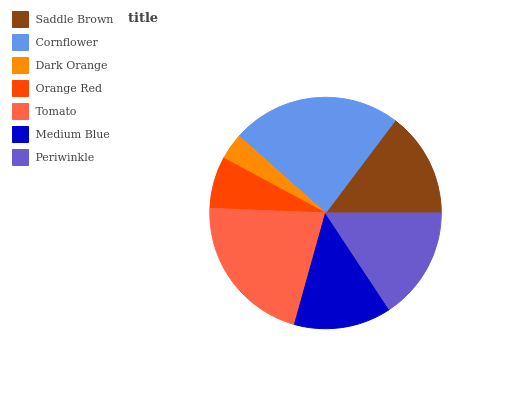Is Dark Orange the minimum?
Answer yes or no. Yes. Is Cornflower the maximum?
Answer yes or no. Yes. Is Cornflower the minimum?
Answer yes or no. No. Is Dark Orange the maximum?
Answer yes or no. No. Is Cornflower greater than Dark Orange?
Answer yes or no. Yes. Is Dark Orange less than Cornflower?
Answer yes or no. Yes. Is Dark Orange greater than Cornflower?
Answer yes or no. No. Is Cornflower less than Dark Orange?
Answer yes or no. No. Is Saddle Brown the high median?
Answer yes or no. Yes. Is Saddle Brown the low median?
Answer yes or no. Yes. Is Orange Red the high median?
Answer yes or no. No. Is Periwinkle the low median?
Answer yes or no. No. 